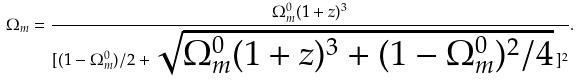Convert formula to latex. <formula><loc_0><loc_0><loc_500><loc_500>\Omega _ { m } = \frac { \Omega _ { m } ^ { 0 } ( 1 + z ) ^ { 3 } } { [ ( 1 - \Omega _ { m } ^ { 0 } ) / 2 + \sqrt { \Omega _ { m } ^ { 0 } ( 1 + z ) ^ { 3 } + ( 1 - \Omega _ { m } ^ { 0 } ) ^ { 2 } / 4 } \, ] ^ { 2 } } .</formula> 